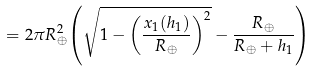Convert formula to latex. <formula><loc_0><loc_0><loc_500><loc_500>= 2 \pi { R _ { \oplus } ^ { 2 } } { \left ( { { \sqrt { 1 - { \left ( { \frac { x _ { 1 } ( { h _ { 1 } } ) } { R _ { \oplus } } } \right ) ^ { 2 } } } } - { \frac { R _ { \oplus } } { R _ { \oplus } + { h _ { 1 } } } } } \right ) }</formula> 